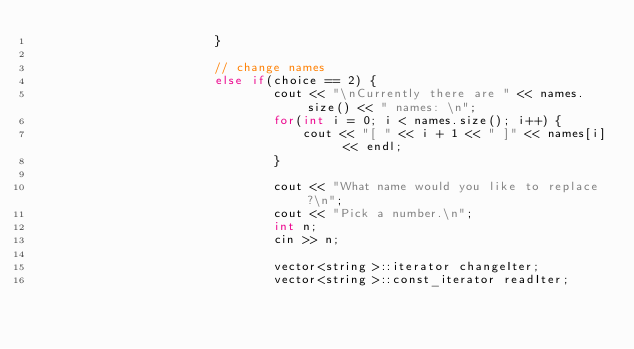Convert code to text. <code><loc_0><loc_0><loc_500><loc_500><_C++_>						}

						// change names
						else if(choice == 2) {
								cout << "\nCurrently there are " << names.size() << " names: \n";
								for(int i = 0; i < names.size(); i++) {
									cout << "[ " << i + 1 << " ]" << names[i] << endl;
								}

								cout << "What name would you like to replace?\n";
								cout << "Pick a number.\n";
								int n;
								cin >> n;

								vector<string>::iterator changeIter;
								vector<string>::const_iterator readIter;
</code> 